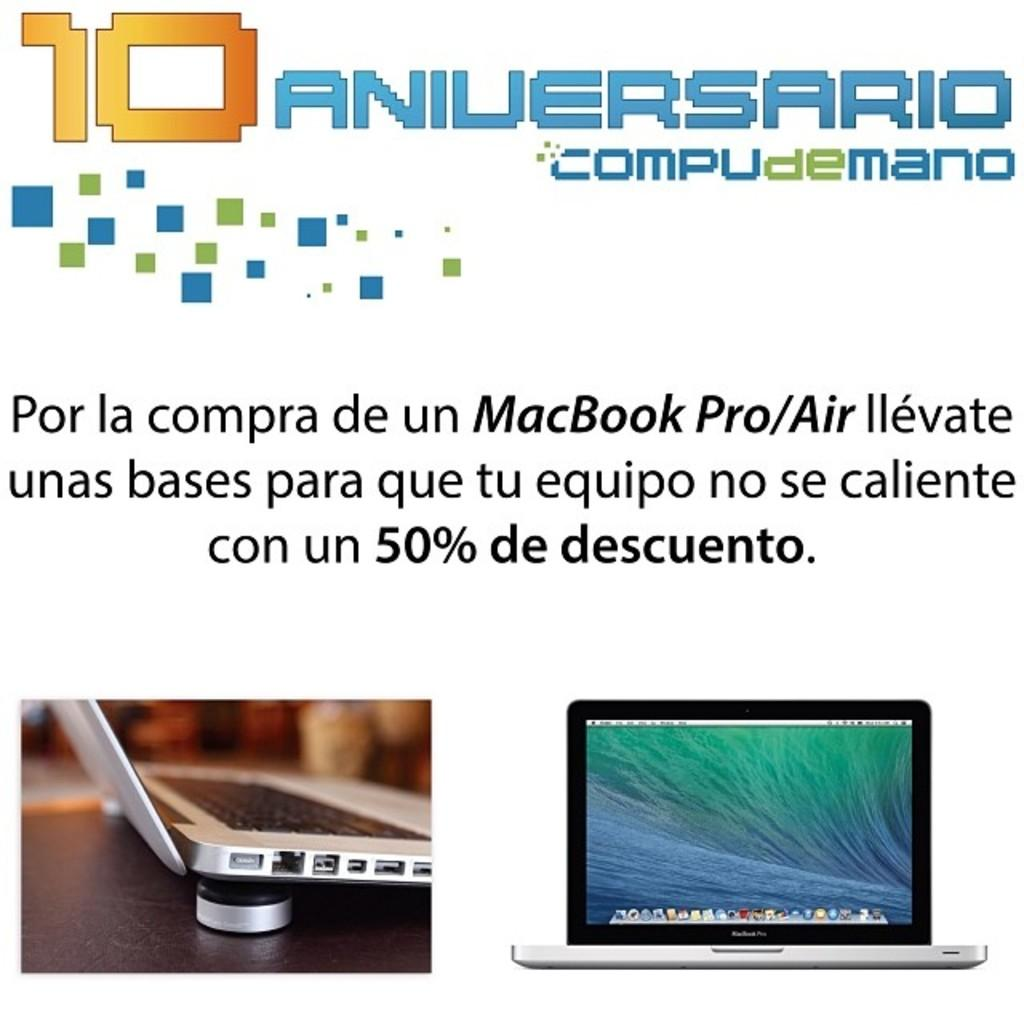<image>
Describe the image concisely. The product being displayed is a Macbook Pro 